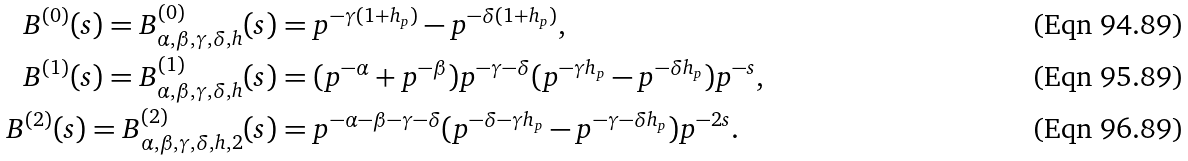<formula> <loc_0><loc_0><loc_500><loc_500>B ^ { ( 0 ) } ( s ) = B ^ { ( 0 ) } _ { \alpha , \beta , \gamma , \delta , h } ( s ) & = p ^ { - \gamma ( 1 + h _ { p } ) } - p ^ { - \delta ( 1 + h _ { p } ) } , \\ B ^ { ( 1 ) } ( s ) = B ^ { ( 1 ) } _ { \alpha , \beta , \gamma , \delta , h } ( s ) & = ( p ^ { - \alpha } + p ^ { - \beta } ) p ^ { - \gamma - \delta } ( p ^ { - \gamma h _ { p } } - p ^ { - \delta h _ { p } } ) p ^ { - s } , \\ B ^ { ( 2 ) } ( s ) = B ^ { ( 2 ) } _ { \alpha , \beta , \gamma , \delta , h , 2 } ( s ) & = p ^ { - \alpha - \beta - \gamma - \delta } ( p ^ { - \delta - \gamma h _ { p } } - p ^ { - \gamma - \delta h _ { p } } ) p ^ { - 2 s } .</formula> 